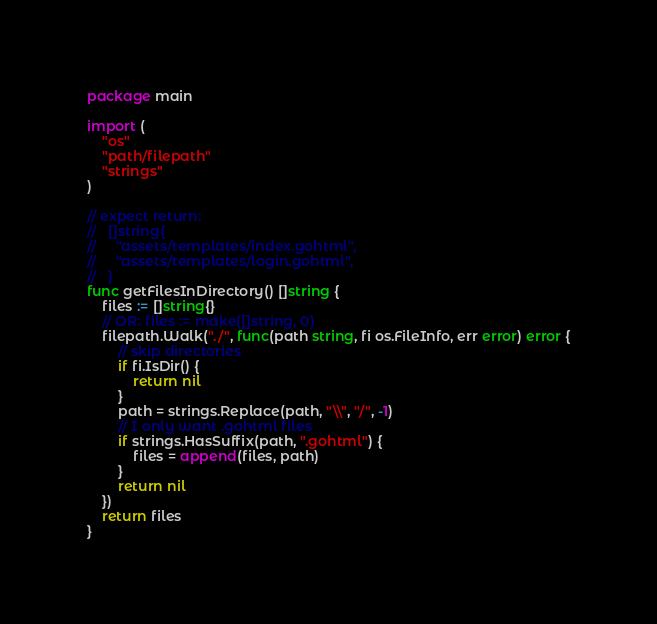Convert code to text. <code><loc_0><loc_0><loc_500><loc_500><_Go_>package main

import (
	"os"
	"path/filepath"
	"strings"
)

// expect return:
//   []string{
//     "assets/templates/index.gohtml",
//     "assets/templates/login.gohtml",
//   }
func getFilesInDirectory() []string {
	files := []string{}
	// OR: files := make([]string, 0)
	filepath.Walk("./", func(path string, fi os.FileInfo, err error) error {
		// skip directories
		if fi.IsDir() {
			return nil
		}
		path = strings.Replace(path, "\\", "/", -1)
		// I only want .gohtml files
		if strings.HasSuffix(path, ".gohtml") {
			files = append(files, path)
		}
		return nil
	})
	return files
}
</code> 